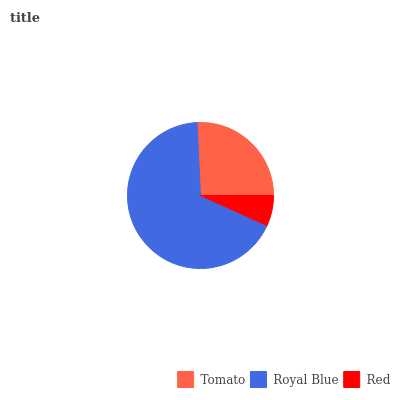Is Red the minimum?
Answer yes or no. Yes. Is Royal Blue the maximum?
Answer yes or no. Yes. Is Royal Blue the minimum?
Answer yes or no. No. Is Red the maximum?
Answer yes or no. No. Is Royal Blue greater than Red?
Answer yes or no. Yes. Is Red less than Royal Blue?
Answer yes or no. Yes. Is Red greater than Royal Blue?
Answer yes or no. No. Is Royal Blue less than Red?
Answer yes or no. No. Is Tomato the high median?
Answer yes or no. Yes. Is Tomato the low median?
Answer yes or no. Yes. Is Royal Blue the high median?
Answer yes or no. No. Is Royal Blue the low median?
Answer yes or no. No. 